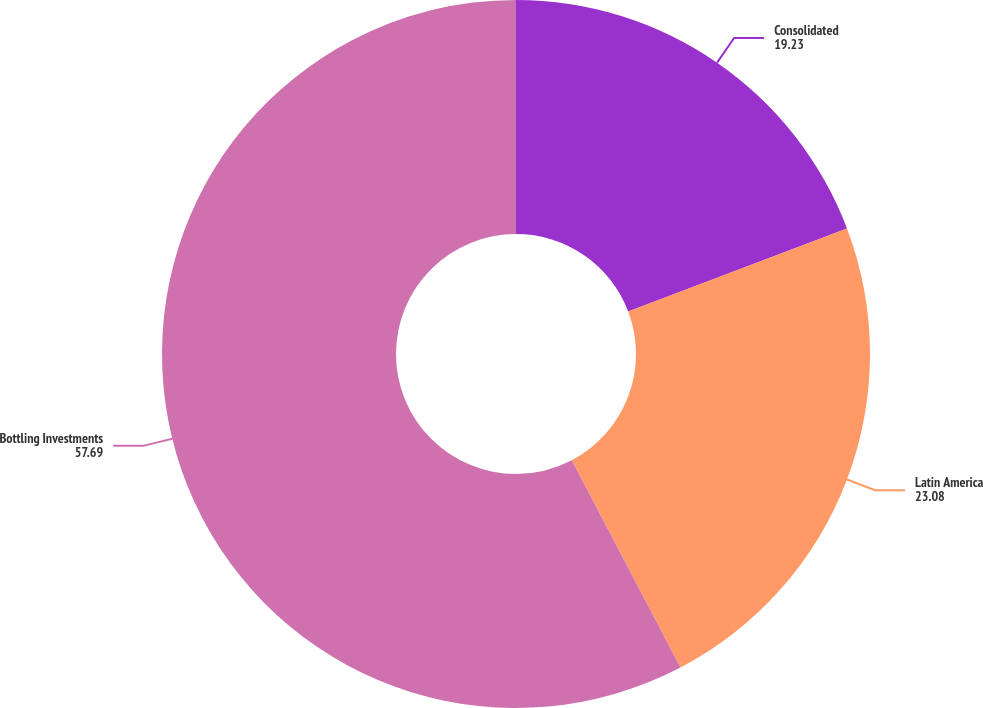Convert chart to OTSL. <chart><loc_0><loc_0><loc_500><loc_500><pie_chart><fcel>Consolidated<fcel>Latin America<fcel>Bottling Investments<nl><fcel>19.23%<fcel>23.08%<fcel>57.69%<nl></chart> 